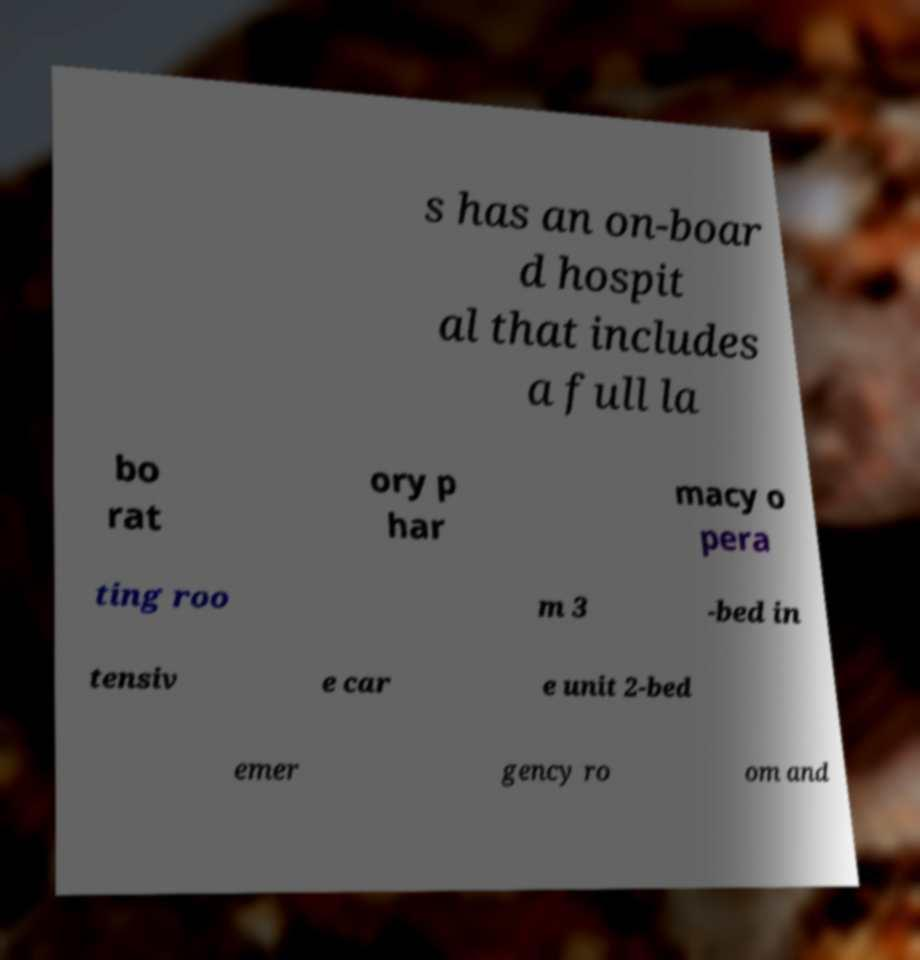There's text embedded in this image that I need extracted. Can you transcribe it verbatim? s has an on-boar d hospit al that includes a full la bo rat ory p har macy o pera ting roo m 3 -bed in tensiv e car e unit 2-bed emer gency ro om and 